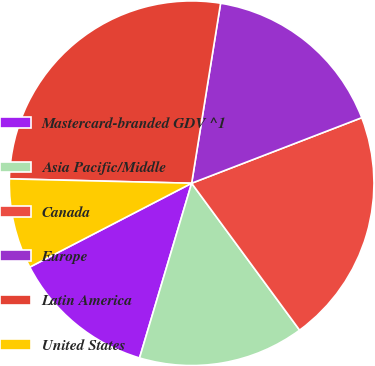Convert chart. <chart><loc_0><loc_0><loc_500><loc_500><pie_chart><fcel>Mastercard-branded GDV ^1<fcel>Asia Pacific/Middle<fcel>Canada<fcel>Europe<fcel>Latin America<fcel>United States<nl><fcel>12.78%<fcel>14.7%<fcel>20.77%<fcel>16.61%<fcel>27.16%<fcel>7.99%<nl></chart> 